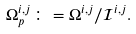Convert formula to latex. <formula><loc_0><loc_0><loc_500><loc_500>\Omega _ { p } ^ { i , j } \colon = \Omega ^ { i , j } / \mathcal { I } ^ { i , j } .</formula> 